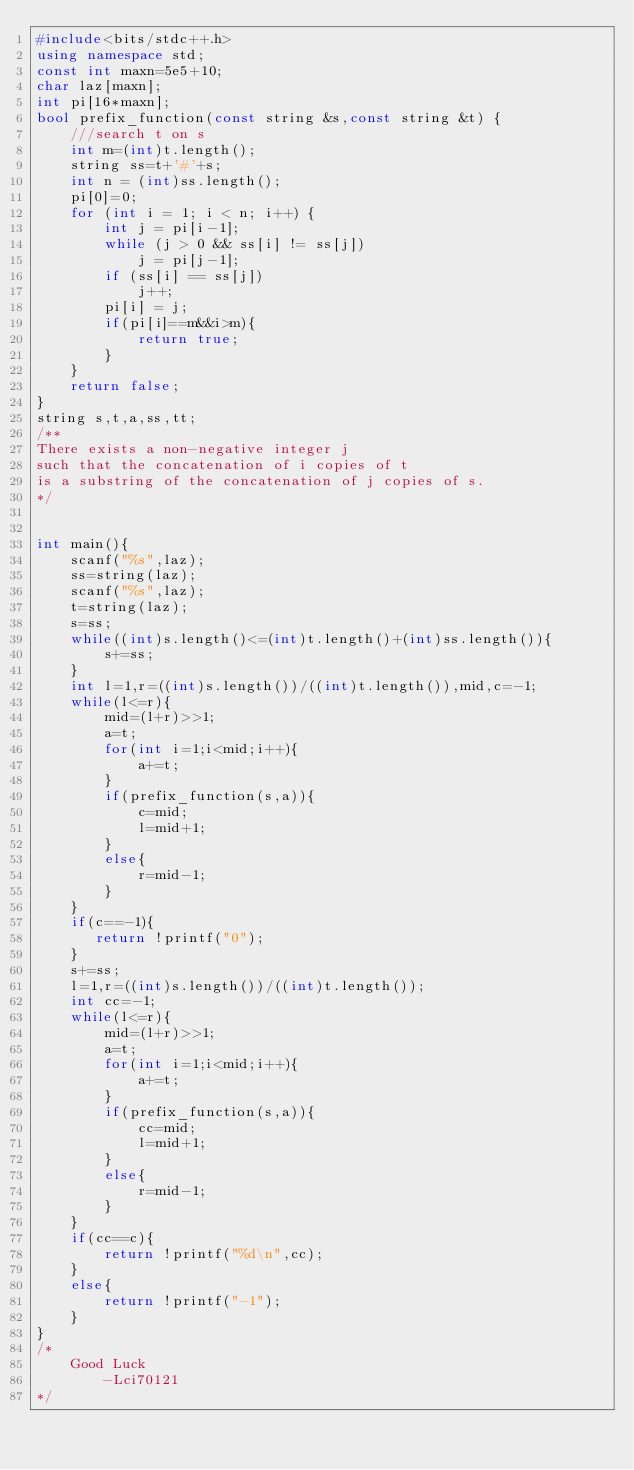<code> <loc_0><loc_0><loc_500><loc_500><_C++_>#include<bits/stdc++.h>
using namespace std;
const int maxn=5e5+10;
char laz[maxn];
int pi[16*maxn];
bool prefix_function(const string &s,const string &t) {
    ///search t on s
    int m=(int)t.length();
    string ss=t+'#'+s;
    int n = (int)ss.length();
    pi[0]=0;
    for (int i = 1; i < n; i++) {
        int j = pi[i-1];
        while (j > 0 && ss[i] != ss[j])
            j = pi[j-1];
        if (ss[i] == ss[j])
            j++;
        pi[i] = j;
        if(pi[i]==m&&i>m){
            return true;
        }
    }
    return false;
}
string s,t,a,ss,tt;
/**
There exists a non-negative integer j
such that the concatenation of i copies of t
is a substring of the concatenation of j copies of s.
*/


int main(){
    scanf("%s",laz);
    ss=string(laz);
    scanf("%s",laz);
    t=string(laz);
    s=ss;
    while((int)s.length()<=(int)t.length()+(int)ss.length()){
        s+=ss;
    }
    int l=1,r=((int)s.length())/((int)t.length()),mid,c=-1;
    while(l<=r){
        mid=(l+r)>>1;
        a=t;
        for(int i=1;i<mid;i++){
            a+=t;
        }
        if(prefix_function(s,a)){
            c=mid;
            l=mid+1;
        }
        else{
            r=mid-1;
        }
    }
    if(c==-1){
       return !printf("0");
    }
    s+=ss;
    l=1,r=((int)s.length())/((int)t.length());
    int cc=-1;
    while(l<=r){
        mid=(l+r)>>1;
        a=t;
        for(int i=1;i<mid;i++){
            a+=t;
        }
        if(prefix_function(s,a)){
            cc=mid;
            l=mid+1;
        }
        else{
            r=mid-1;
        }
    }
    if(cc==c){
        return !printf("%d\n",cc);
    }
    else{
        return !printf("-1");
    }
}
/*
    Good Luck
        -Lci70121
*/
</code> 